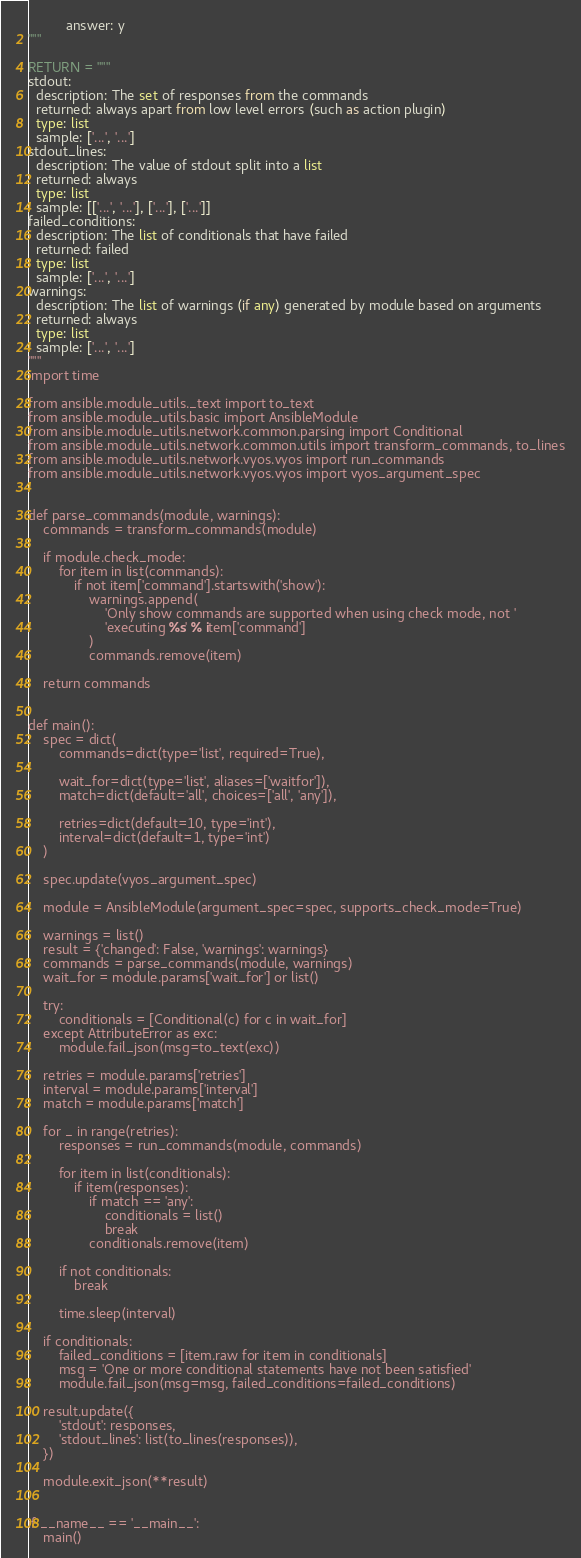<code> <loc_0><loc_0><loc_500><loc_500><_Python_>          answer: y
"""

RETURN = """
stdout:
  description: The set of responses from the commands
  returned: always apart from low level errors (such as action plugin)
  type: list
  sample: ['...', '...']
stdout_lines:
  description: The value of stdout split into a list
  returned: always
  type: list
  sample: [['...', '...'], ['...'], ['...']]
failed_conditions:
  description: The list of conditionals that have failed
  returned: failed
  type: list
  sample: ['...', '...']
warnings:
  description: The list of warnings (if any) generated by module based on arguments
  returned: always
  type: list
  sample: ['...', '...']
"""
import time

from ansible.module_utils._text import to_text
from ansible.module_utils.basic import AnsibleModule
from ansible.module_utils.network.common.parsing import Conditional
from ansible.module_utils.network.common.utils import transform_commands, to_lines
from ansible.module_utils.network.vyos.vyos import run_commands
from ansible.module_utils.network.vyos.vyos import vyos_argument_spec


def parse_commands(module, warnings):
    commands = transform_commands(module)

    if module.check_mode:
        for item in list(commands):
            if not item['command'].startswith('show'):
                warnings.append(
                    'Only show commands are supported when using check mode, not '
                    'executing %s' % item['command']
                )
                commands.remove(item)

    return commands


def main():
    spec = dict(
        commands=dict(type='list', required=True),

        wait_for=dict(type='list', aliases=['waitfor']),
        match=dict(default='all', choices=['all', 'any']),

        retries=dict(default=10, type='int'),
        interval=dict(default=1, type='int')
    )

    spec.update(vyos_argument_spec)

    module = AnsibleModule(argument_spec=spec, supports_check_mode=True)

    warnings = list()
    result = {'changed': False, 'warnings': warnings}
    commands = parse_commands(module, warnings)
    wait_for = module.params['wait_for'] or list()

    try:
        conditionals = [Conditional(c) for c in wait_for]
    except AttributeError as exc:
        module.fail_json(msg=to_text(exc))

    retries = module.params['retries']
    interval = module.params['interval']
    match = module.params['match']

    for _ in range(retries):
        responses = run_commands(module, commands)

        for item in list(conditionals):
            if item(responses):
                if match == 'any':
                    conditionals = list()
                    break
                conditionals.remove(item)

        if not conditionals:
            break

        time.sleep(interval)

    if conditionals:
        failed_conditions = [item.raw for item in conditionals]
        msg = 'One or more conditional statements have not been satisfied'
        module.fail_json(msg=msg, failed_conditions=failed_conditions)

    result.update({
        'stdout': responses,
        'stdout_lines': list(to_lines(responses)),
    })

    module.exit_json(**result)


if __name__ == '__main__':
    main()
</code> 